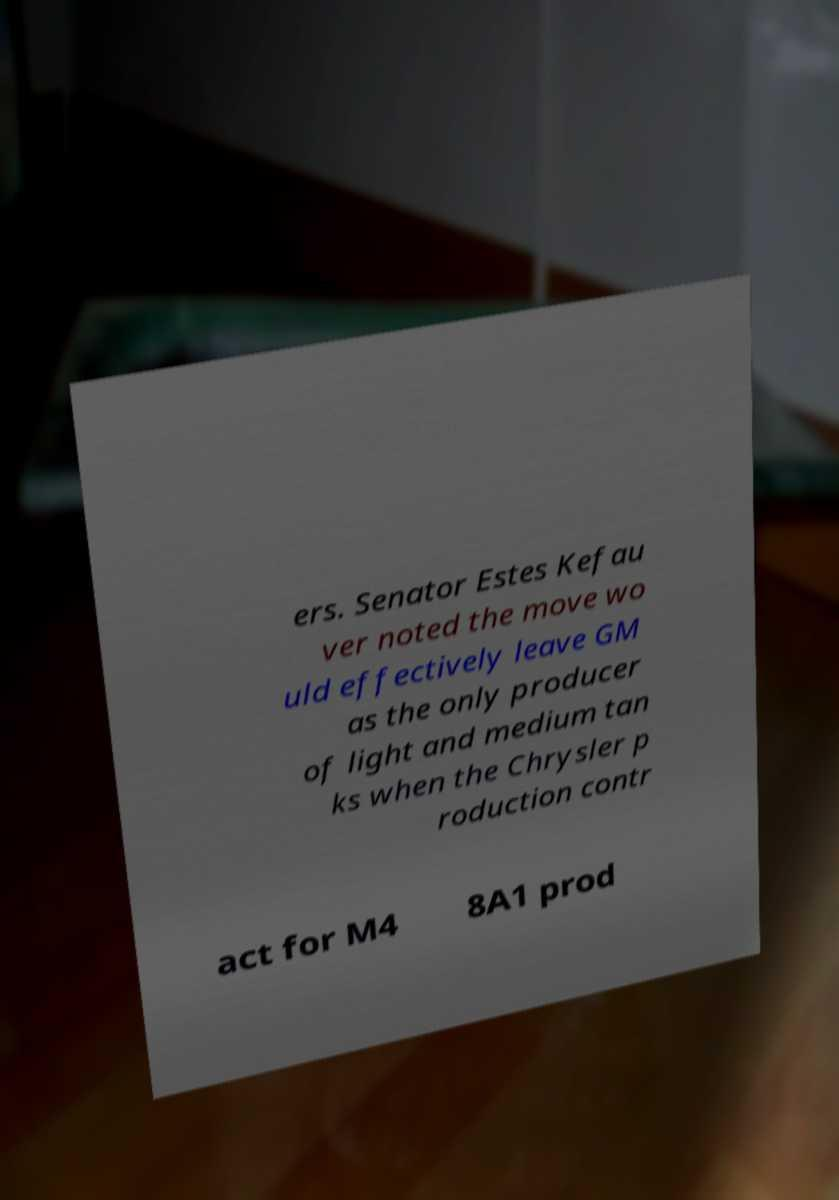Can you read and provide the text displayed in the image?This photo seems to have some interesting text. Can you extract and type it out for me? ers. Senator Estes Kefau ver noted the move wo uld effectively leave GM as the only producer of light and medium tan ks when the Chrysler p roduction contr act for M4 8A1 prod 